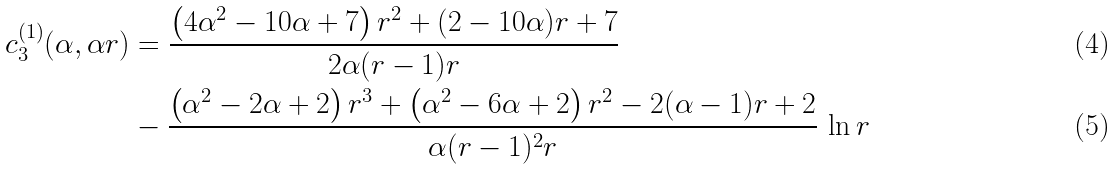<formula> <loc_0><loc_0><loc_500><loc_500>c _ { 3 } ^ { ( 1 ) } ( \alpha , \alpha r ) & = \frac { \left ( 4 \alpha ^ { 2 } - 1 0 \alpha + 7 \right ) r ^ { 2 } + ( 2 - 1 0 \alpha ) r + 7 } { 2 \alpha ( r - 1 ) r } \\ & - \frac { \left ( \alpha ^ { 2 } - 2 \alpha + 2 \right ) r ^ { 3 } + \left ( \alpha ^ { 2 } - 6 \alpha + 2 \right ) r ^ { 2 } - 2 ( \alpha - 1 ) r + 2 } { \alpha ( r - 1 ) ^ { 2 } r } \, \ln r</formula> 